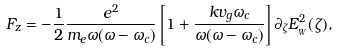<formula> <loc_0><loc_0><loc_500><loc_500>F _ { z } = - \frac { 1 } { 2 } \frac { e ^ { 2 } } { m _ { e } \omega ( \omega - \omega _ { c } ) } \left [ 1 + \frac { k v _ { g } \omega _ { c } } { \omega ( \omega - \omega _ { c } ) } \right ] \partial _ { \zeta } E _ { _ { W } } ^ { 2 } ( \zeta ) ,</formula> 